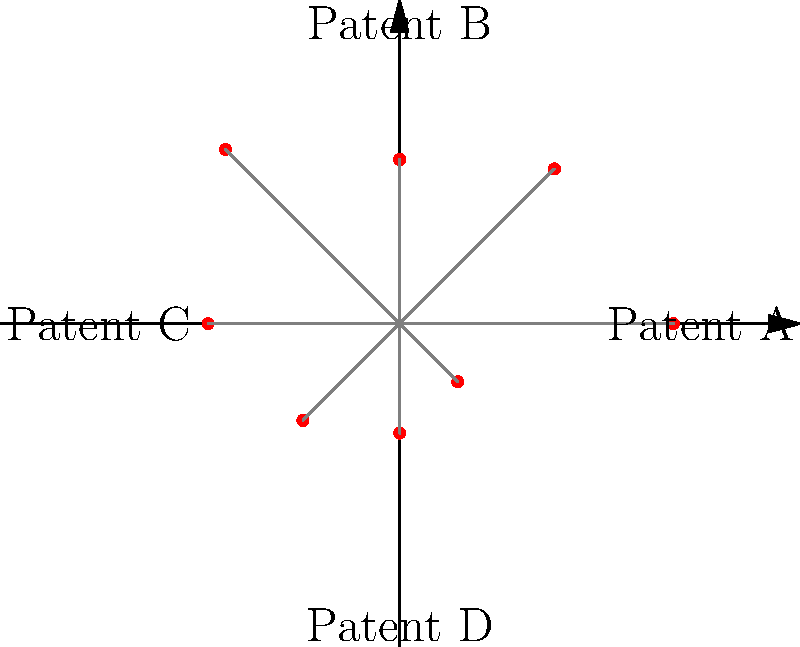In the polar dendrogram representing patent similarities, which patent appears to be most similar to Patent A based on its proximity? To determine which patent is most similar to Patent A in this polar dendrogram:

1. Identify Patent A's position: It's located on the positive x-axis (0° angle).
2. Observe the positions of other data points (patents) relative to Patent A.
3. The closer a point is to Patent A, the more similar the patents are.
4. Analyze the angular distance and radial distance of each point from Patent A.
5. The point at a 45° angle (northeast direction) is closest to Patent A.
6. This point represents the patent most similar to Patent A.
7. The other patents are further away, indicating less similarity.

The patent represented by the point at 45° is most similar to Patent A due to its proximity in both angular and radial dimensions.
Answer: The patent at 45° angle (northeast direction) 